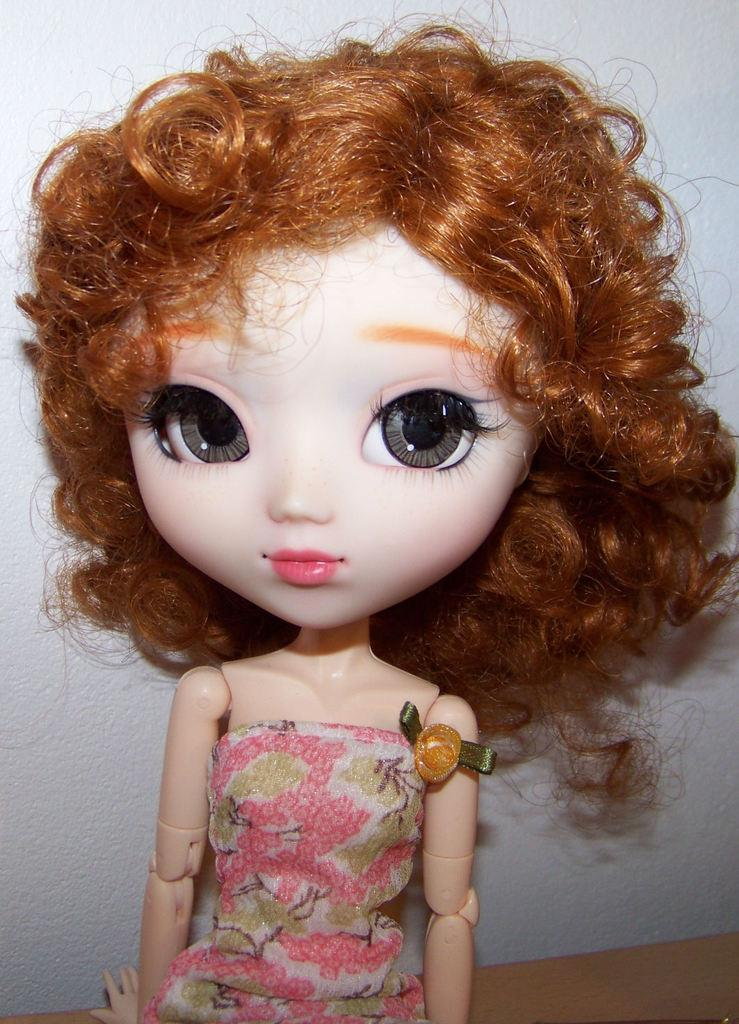What object can be seen in the image? There is a toy in the image. What can be seen in the background of the image? There is a wall in the background of the image. Is your friend coughing in the image? There is no person present in the image, so it is not possible to determine if a friend is coughing. 